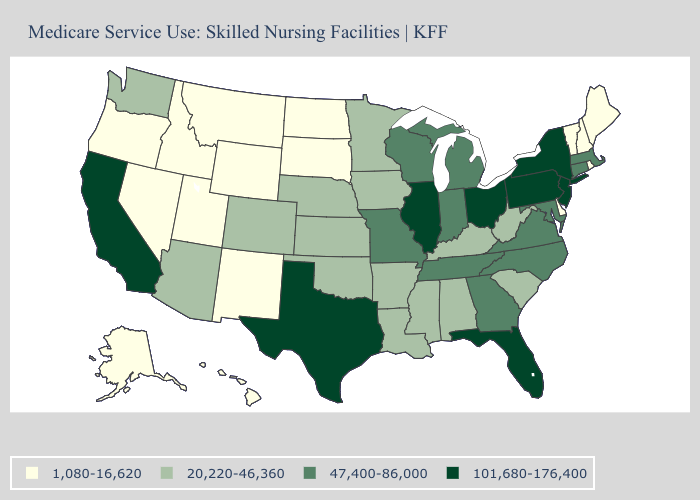Name the states that have a value in the range 47,400-86,000?
Be succinct. Connecticut, Georgia, Indiana, Maryland, Massachusetts, Michigan, Missouri, North Carolina, Tennessee, Virginia, Wisconsin. Among the states that border Michigan , which have the lowest value?
Answer briefly. Indiana, Wisconsin. Name the states that have a value in the range 20,220-46,360?
Be succinct. Alabama, Arizona, Arkansas, Colorado, Iowa, Kansas, Kentucky, Louisiana, Minnesota, Mississippi, Nebraska, Oklahoma, South Carolina, Washington, West Virginia. What is the value of Colorado?
Be succinct. 20,220-46,360. What is the lowest value in states that border Florida?
Short answer required. 20,220-46,360. How many symbols are there in the legend?
Keep it brief. 4. What is the value of Massachusetts?
Quick response, please. 47,400-86,000. Which states have the lowest value in the USA?
Write a very short answer. Alaska, Delaware, Hawaii, Idaho, Maine, Montana, Nevada, New Hampshire, New Mexico, North Dakota, Oregon, Rhode Island, South Dakota, Utah, Vermont, Wyoming. What is the value of Illinois?
Keep it brief. 101,680-176,400. What is the highest value in the USA?
Answer briefly. 101,680-176,400. Among the states that border Georgia , which have the highest value?
Be succinct. Florida. Among the states that border Alabama , does Florida have the highest value?
Be succinct. Yes. Name the states that have a value in the range 47,400-86,000?
Quick response, please. Connecticut, Georgia, Indiana, Maryland, Massachusetts, Michigan, Missouri, North Carolina, Tennessee, Virginia, Wisconsin. Does the first symbol in the legend represent the smallest category?
Quick response, please. Yes. Does Vermont have the lowest value in the USA?
Be succinct. Yes. 